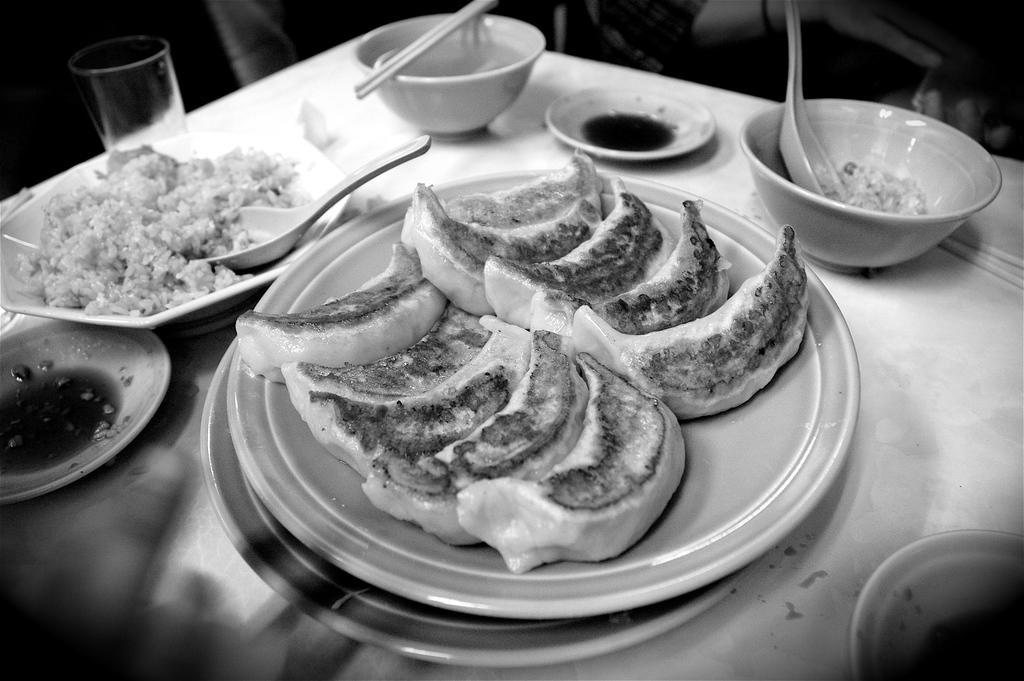Could you give a brief overview of what you see in this image? In this picture we can see some food on the plates. This is the table, on the table there are plates, glass, and bowls. And this is the spoon and these are the chopsticks. 